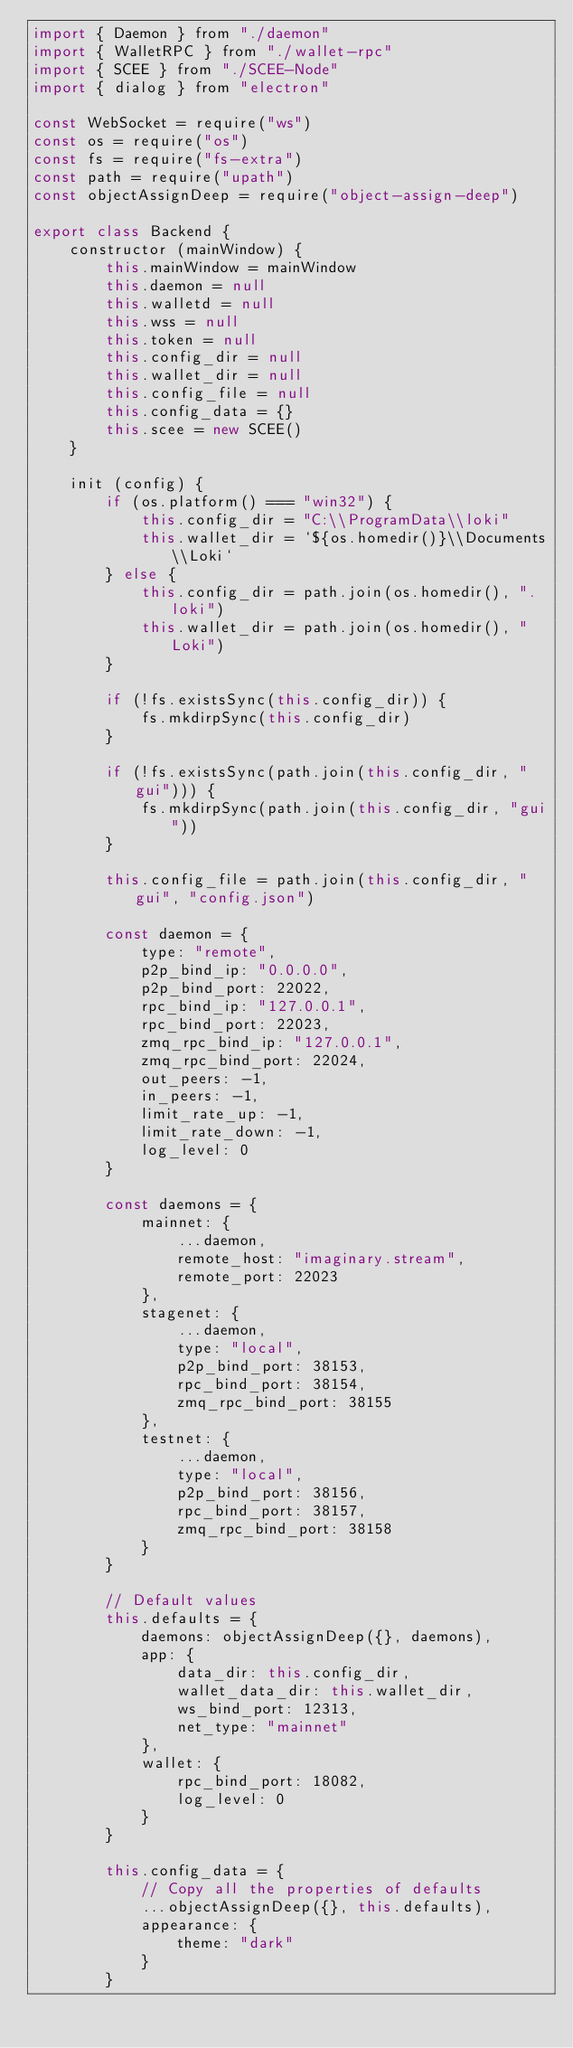<code> <loc_0><loc_0><loc_500><loc_500><_JavaScript_>import { Daemon } from "./daemon"
import { WalletRPC } from "./wallet-rpc"
import { SCEE } from "./SCEE-Node"
import { dialog } from "electron"

const WebSocket = require("ws")
const os = require("os")
const fs = require("fs-extra")
const path = require("upath")
const objectAssignDeep = require("object-assign-deep")

export class Backend {
    constructor (mainWindow) {
        this.mainWindow = mainWindow
        this.daemon = null
        this.walletd = null
        this.wss = null
        this.token = null
        this.config_dir = null
        this.wallet_dir = null
        this.config_file = null
        this.config_data = {}
        this.scee = new SCEE()
    }

    init (config) {
        if (os.platform() === "win32") {
            this.config_dir = "C:\\ProgramData\\loki"
            this.wallet_dir = `${os.homedir()}\\Documents\\Loki`
        } else {
            this.config_dir = path.join(os.homedir(), ".loki")
            this.wallet_dir = path.join(os.homedir(), "Loki")
        }

        if (!fs.existsSync(this.config_dir)) {
            fs.mkdirpSync(this.config_dir)
        }

        if (!fs.existsSync(path.join(this.config_dir, "gui"))) {
            fs.mkdirpSync(path.join(this.config_dir, "gui"))
        }

        this.config_file = path.join(this.config_dir, "gui", "config.json")

        const daemon = {
            type: "remote",
            p2p_bind_ip: "0.0.0.0",
            p2p_bind_port: 22022,
            rpc_bind_ip: "127.0.0.1",
            rpc_bind_port: 22023,
            zmq_rpc_bind_ip: "127.0.0.1",
            zmq_rpc_bind_port: 22024,
            out_peers: -1,
            in_peers: -1,
            limit_rate_up: -1,
            limit_rate_down: -1,
            log_level: 0
        }

        const daemons = {
            mainnet: {
                ...daemon,
                remote_host: "imaginary.stream",
                remote_port: 22023
            },
            stagenet: {
                ...daemon,
                type: "local",
                p2p_bind_port: 38153,
                rpc_bind_port: 38154,
                zmq_rpc_bind_port: 38155
            },
            testnet: {
                ...daemon,
                type: "local",
                p2p_bind_port: 38156,
                rpc_bind_port: 38157,
                zmq_rpc_bind_port: 38158
            }
        }

        // Default values
        this.defaults = {
            daemons: objectAssignDeep({}, daemons),
            app: {
                data_dir: this.config_dir,
                wallet_data_dir: this.wallet_dir,
                ws_bind_port: 12313,
                net_type: "mainnet"
            },
            wallet: {
                rpc_bind_port: 18082,
                log_level: 0
            }
        }

        this.config_data = {
            // Copy all the properties of defaults
            ...objectAssignDeep({}, this.defaults),
            appearance: {
                theme: "dark"
            }
        }
</code> 